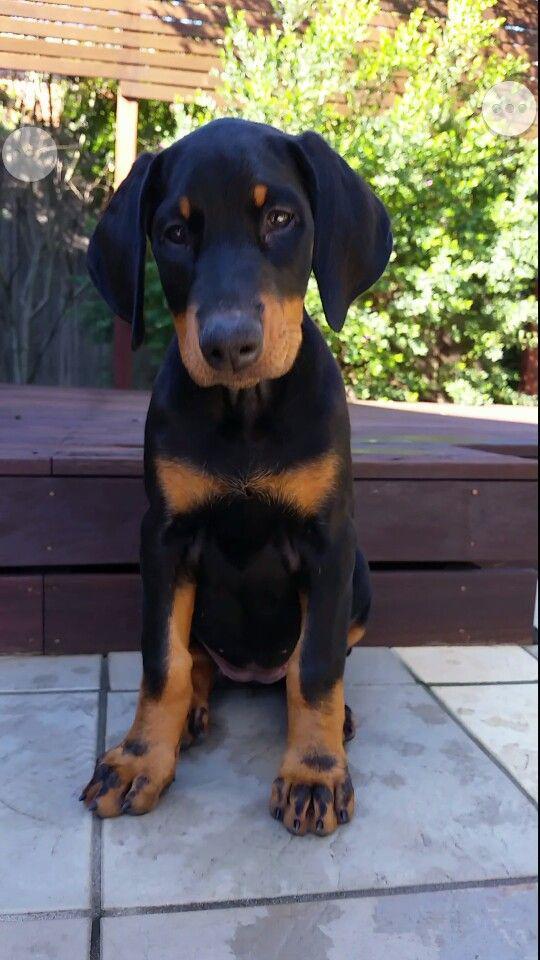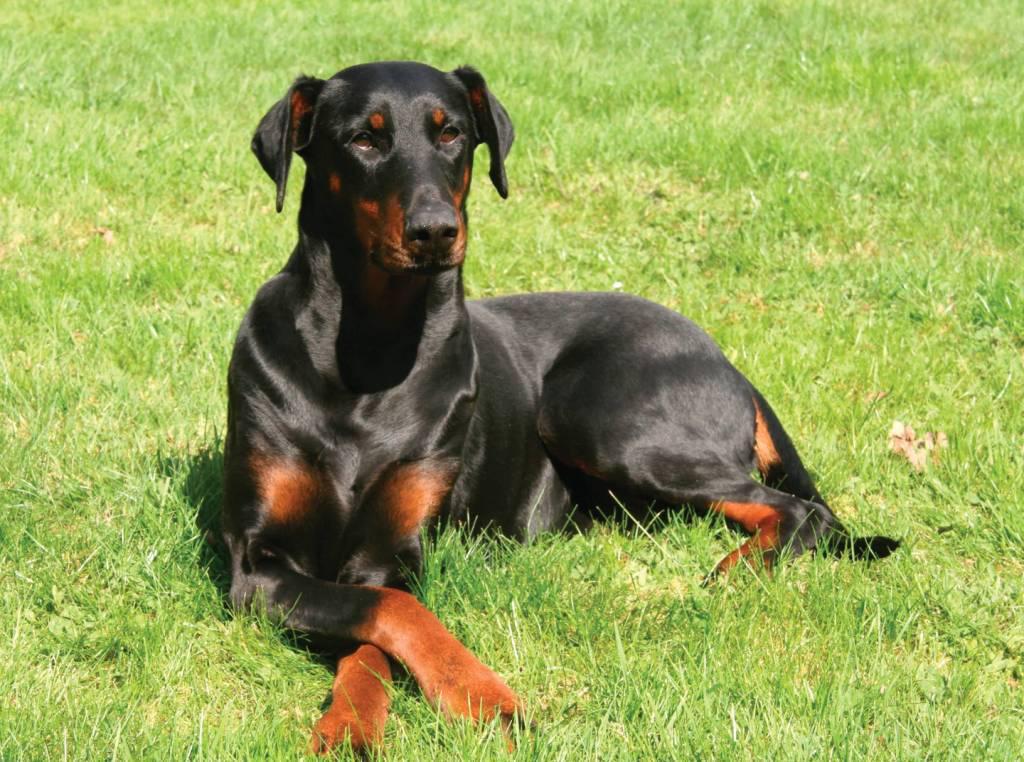The first image is the image on the left, the second image is the image on the right. Considering the images on both sides, is "Each image contains a pair of animals, but one image features puppies and the other features adult dogs." valid? Answer yes or no. No. The first image is the image on the left, the second image is the image on the right. Evaluate the accuracy of this statement regarding the images: "At least one dog is sitting on a tile floor.". Is it true? Answer yes or no. Yes. 